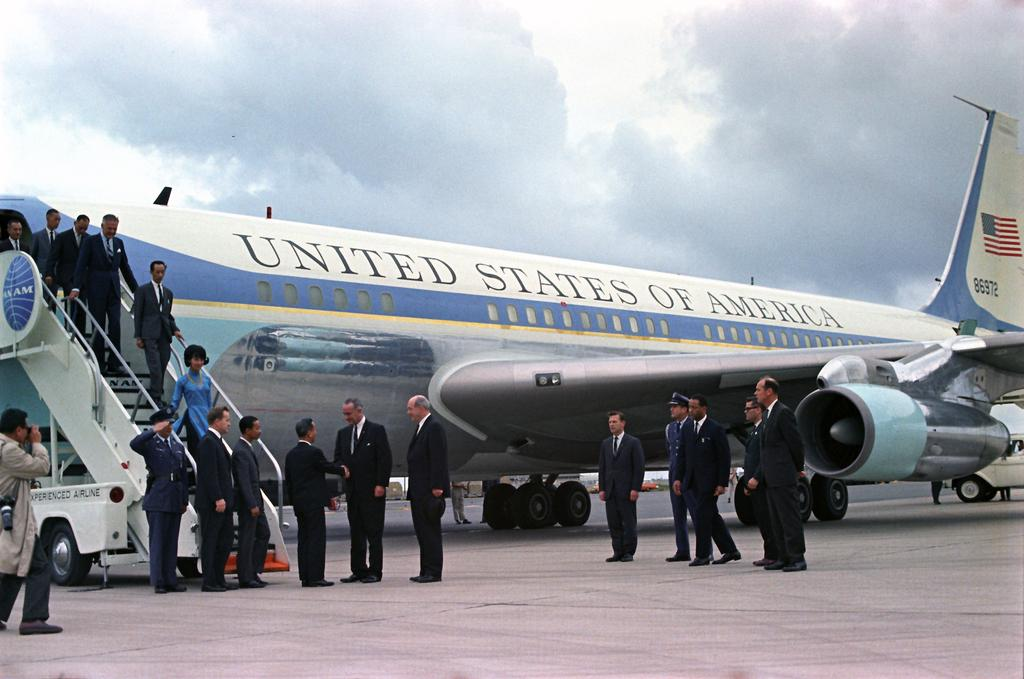<image>
Create a compact narrative representing the image presented. A picture of the united states of america air force one. 